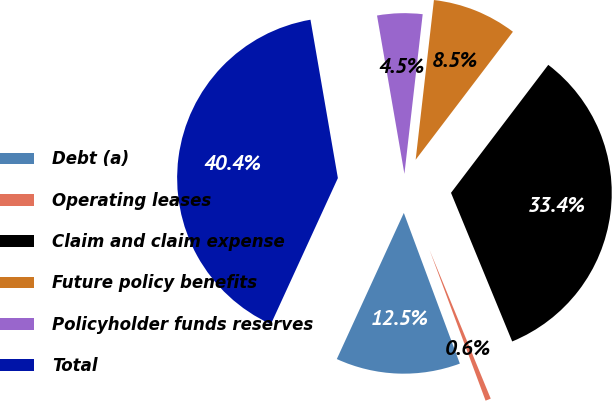Convert chart to OTSL. <chart><loc_0><loc_0><loc_500><loc_500><pie_chart><fcel>Debt (a)<fcel>Operating leases<fcel>Claim and claim expense<fcel>Future policy benefits<fcel>Policyholder funds reserves<fcel>Total<nl><fcel>12.51%<fcel>0.55%<fcel>33.44%<fcel>8.53%<fcel>4.54%<fcel>40.43%<nl></chart> 